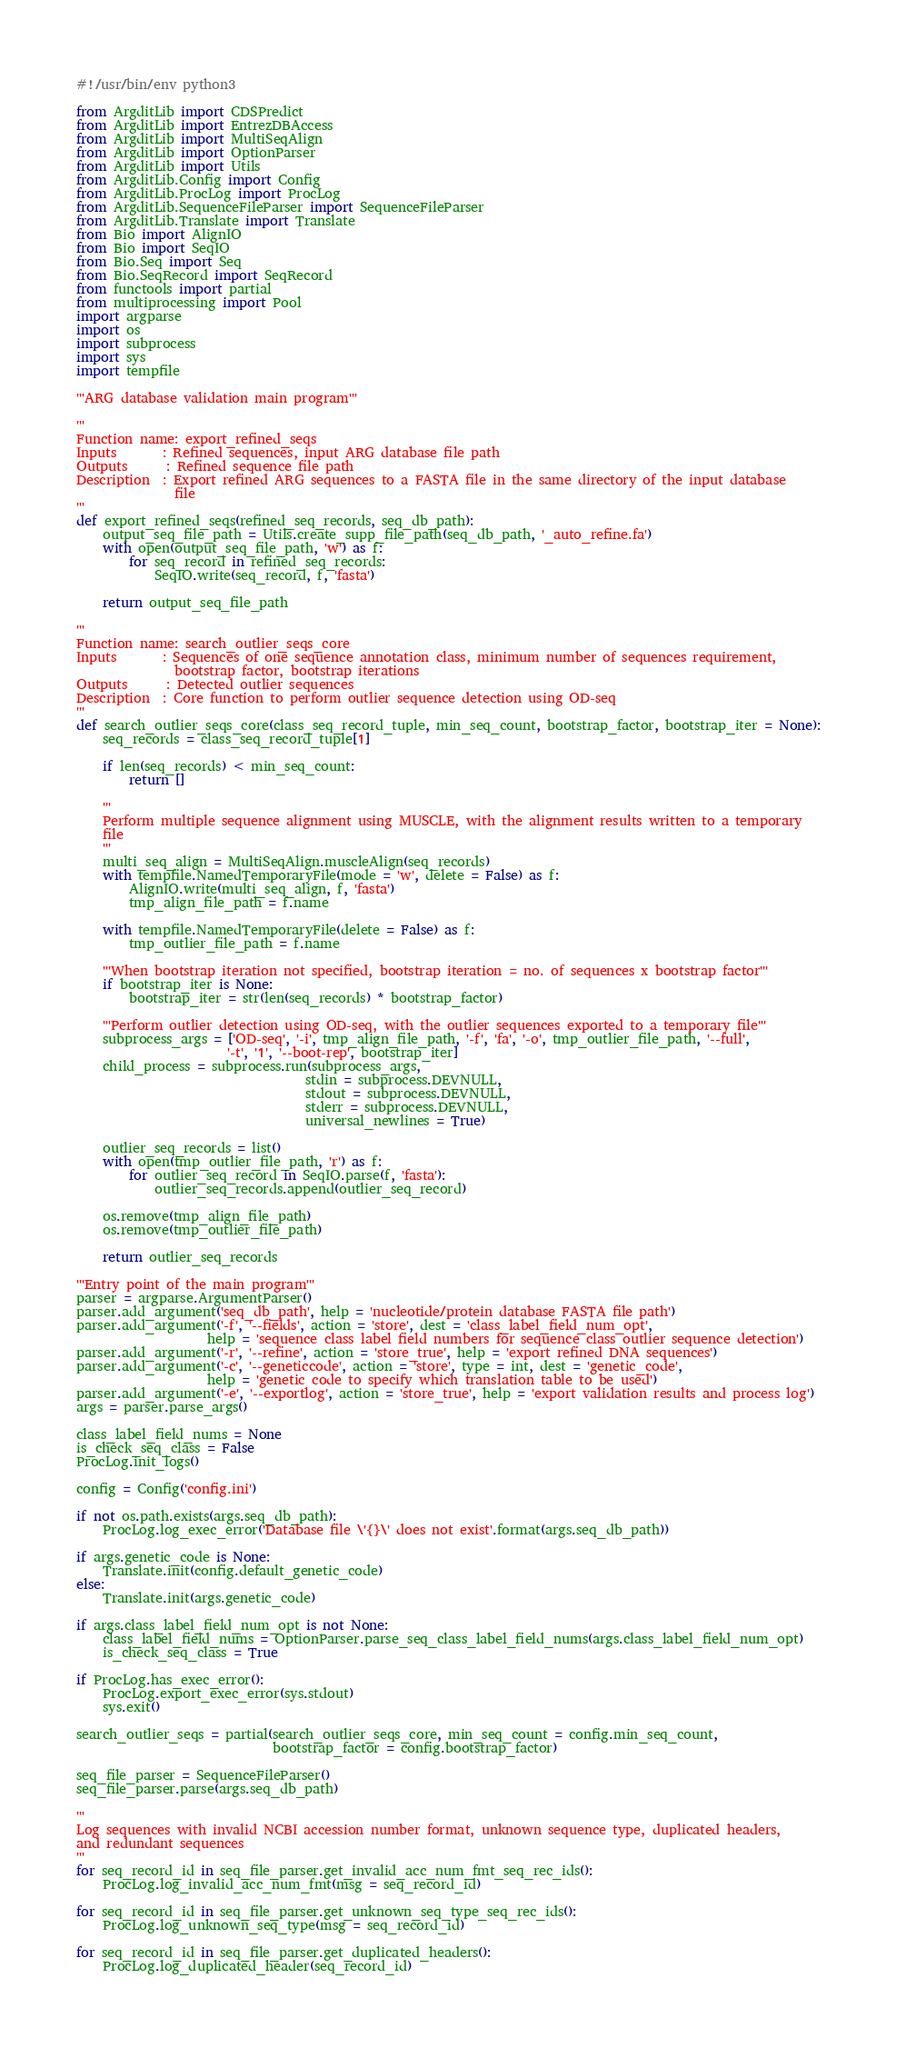<code> <loc_0><loc_0><loc_500><loc_500><_Python_>#!/usr/bin/env python3

from ArgditLib import CDSPredict
from ArgditLib import EntrezDBAccess
from ArgditLib import MultiSeqAlign
from ArgditLib import OptionParser
from ArgditLib import Utils
from ArgditLib.Config import Config
from ArgditLib.ProcLog import ProcLog
from ArgditLib.SequenceFileParser import SequenceFileParser
from ArgditLib.Translate import Translate
from Bio import AlignIO
from Bio import SeqIO
from Bio.Seq import Seq
from Bio.SeqRecord import SeqRecord
from functools import partial
from multiprocessing import Pool
import argparse
import os
import subprocess
import sys
import tempfile

'''ARG database validation main program'''

'''
Function name: export_refined_seqs
Inputs       : Refined sequences, input ARG database file path
Outputs      : Refined sequence file path
Description  : Export refined ARG sequences to a FASTA file in the same directory of the input database
               file
'''
def export_refined_seqs(refined_seq_records, seq_db_path):
    output_seq_file_path = Utils.create_supp_file_path(seq_db_path, '_auto_refine.fa')
    with open(output_seq_file_path, 'w') as f:
        for seq_record in refined_seq_records:
            SeqIO.write(seq_record, f, 'fasta')

    return output_seq_file_path

'''
Function name: search_outlier_seqs_core
Inputs       : Sequences of one sequence annotation class, minimum number of sequences requirement,
               bootstrap factor, bootstrap iterations
Outputs      : Detected outlier sequences
Description  : Core function to perform outlier sequence detection using OD-seq
'''
def search_outlier_seqs_core(class_seq_record_tuple, min_seq_count, bootstrap_factor, bootstrap_iter = None):
    seq_records = class_seq_record_tuple[1]

    if len(seq_records) < min_seq_count:
        return []

    '''
    Perform multiple sequence alignment using MUSCLE, with the alignment results written to a temporary
    file
    '''
    multi_seq_align = MultiSeqAlign.muscleAlign(seq_records)
    with tempfile.NamedTemporaryFile(mode = 'w', delete = False) as f:
        AlignIO.write(multi_seq_align, f, 'fasta')
        tmp_align_file_path = f.name

    with tempfile.NamedTemporaryFile(delete = False) as f:
        tmp_outlier_file_path = f.name

    '''When bootstrap iteration not specified, bootstrap iteration = no. of sequences x bootstrap factor'''
    if bootstrap_iter is None:
        bootstrap_iter = str(len(seq_records) * bootstrap_factor)

    '''Perform outlier detection using OD-seq, with the outlier sequences exported to a temporary file'''
    subprocess_args = ['OD-seq', '-i', tmp_align_file_path, '-f', 'fa', '-o', tmp_outlier_file_path, '--full',
                       '-t', '1', '--boot-rep', bootstrap_iter]
    child_process = subprocess.run(subprocess_args,
                                   stdin = subprocess.DEVNULL,
                                   stdout = subprocess.DEVNULL,
                                   stderr = subprocess.DEVNULL,
                                   universal_newlines = True)

    outlier_seq_records = list()
    with open(tmp_outlier_file_path, 'r') as f:
        for outlier_seq_record in SeqIO.parse(f, 'fasta'):
            outlier_seq_records.append(outlier_seq_record)

    os.remove(tmp_align_file_path)
    os.remove(tmp_outlier_file_path)

    return outlier_seq_records

'''Entry point of the main program'''
parser = argparse.ArgumentParser()
parser.add_argument('seq_db_path', help = 'nucleotide/protein database FASTA file path')
parser.add_argument('-f', '--fields', action = 'store', dest = 'class_label_field_num_opt',
                    help = 'sequence class label field numbers for sequence class outlier sequence detection')
parser.add_argument('-r', '--refine', action = 'store_true', help = 'export refined DNA sequences')
parser.add_argument('-c', '--geneticcode', action = 'store', type = int, dest = 'genetic_code',
                    help = 'genetic code to specify which translation table to be used')
parser.add_argument('-e', '--exportlog', action = 'store_true', help = 'export validation results and process log')
args = parser.parse_args()

class_label_field_nums = None
is_check_seq_class = False
ProcLog.init_logs()

config = Config('config.ini')

if not os.path.exists(args.seq_db_path):
    ProcLog.log_exec_error('Database file \'{}\' does not exist'.format(args.seq_db_path))

if args.genetic_code is None:
    Translate.init(config.default_genetic_code)
else:
    Translate.init(args.genetic_code)

if args.class_label_field_num_opt is not None:
    class_label_field_nums = OptionParser.parse_seq_class_label_field_nums(args.class_label_field_num_opt)
    is_check_seq_class = True

if ProcLog.has_exec_error():
    ProcLog.export_exec_error(sys.stdout)
    sys.exit()

search_outlier_seqs = partial(search_outlier_seqs_core, min_seq_count = config.min_seq_count,
                              bootstrap_factor = config.bootstrap_factor)

seq_file_parser = SequenceFileParser()
seq_file_parser.parse(args.seq_db_path)

'''
Log sequences with invalid NCBI accession number format, unknown sequence type, duplicated headers,
and redundant sequences
'''
for seq_record_id in seq_file_parser.get_invalid_acc_num_fmt_seq_rec_ids():
    ProcLog.log_invalid_acc_num_fmt(msg = seq_record_id)

for seq_record_id in seq_file_parser.get_unknown_seq_type_seq_rec_ids():
    ProcLog.log_unknown_seq_type(msg = seq_record_id)

for seq_record_id in seq_file_parser.get_duplicated_headers():
    ProcLog.log_duplicated_header(seq_record_id)
</code> 